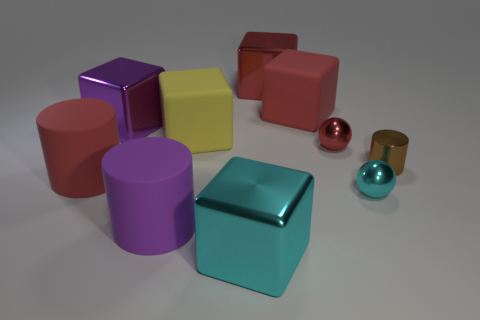Subtract all gray spheres. How many red blocks are left? 2 Subtract all big red metal cubes. How many cubes are left? 4 Subtract all purple cubes. How many cubes are left? 4 Subtract all cylinders. How many objects are left? 7 Subtract all blue cylinders. Subtract all blue spheres. How many cylinders are left? 3 Subtract all purple matte cylinders. Subtract all big matte cylinders. How many objects are left? 7 Add 7 red cubes. How many red cubes are left? 9 Add 2 big yellow matte cubes. How many big yellow matte cubes exist? 3 Subtract 1 red spheres. How many objects are left? 9 